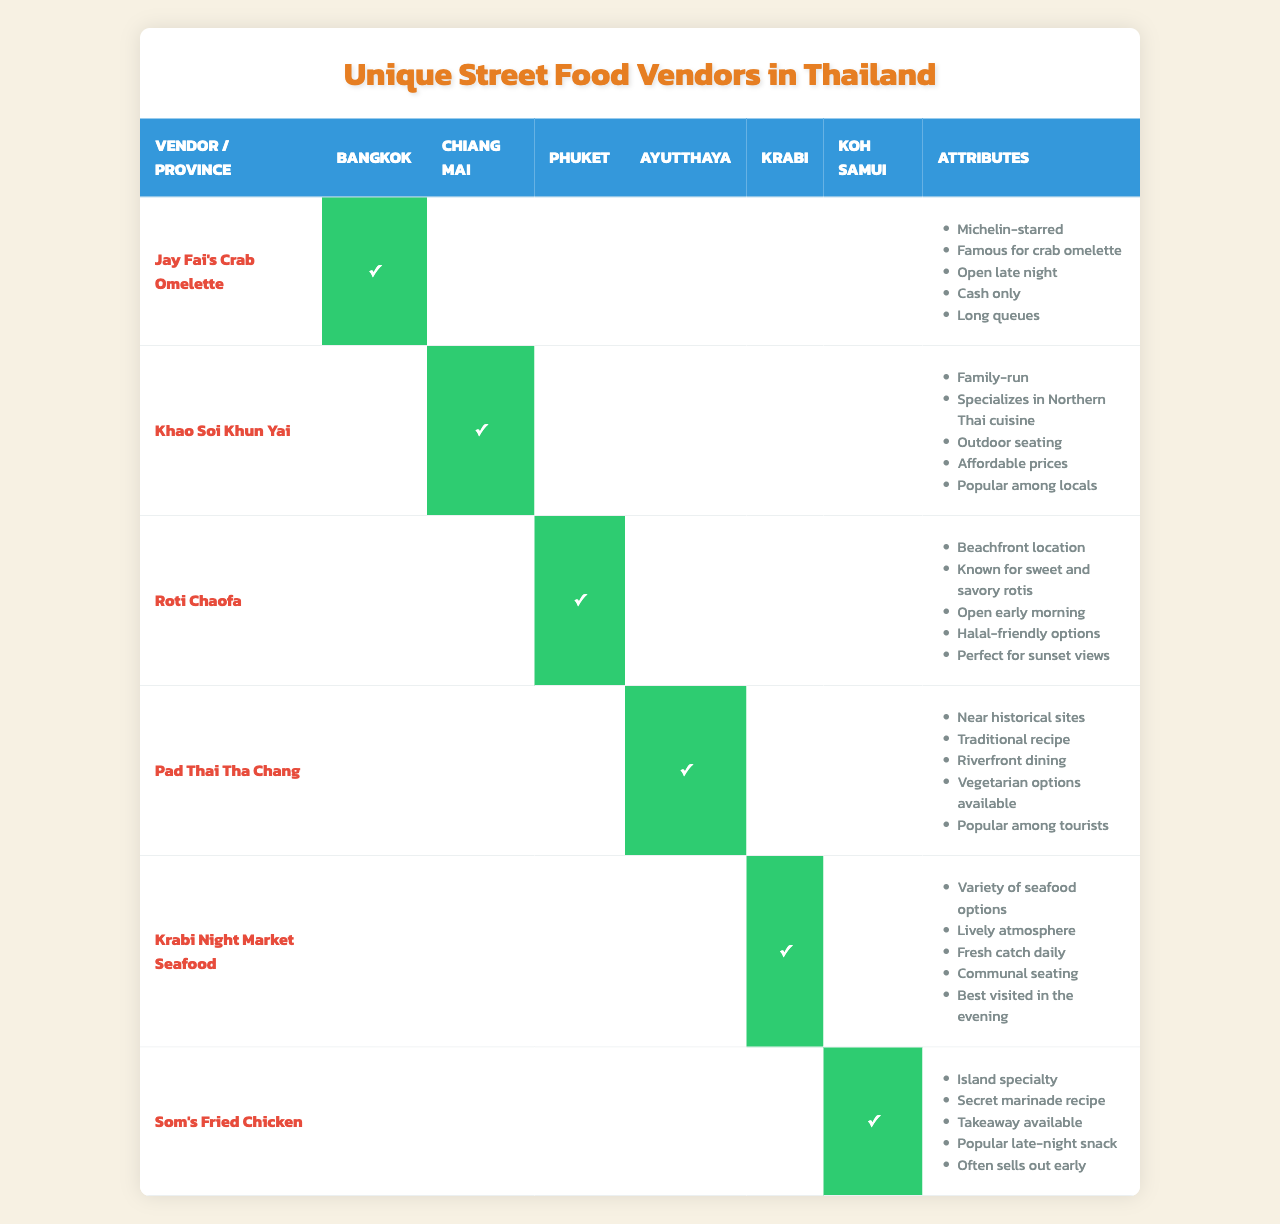What street food vendor is unique to Bangkok? According to the table, "Jay Fai's Crab Omelette" is the vendor listed under Bangkok.
Answer: Jay Fai's Crab Omelette Which vendor is known for Northern Thai cuisine? The table shows that "Khao Soi Khun Yai" specializes in Northern Thai cuisine and is located in Chiang Mai.
Answer: Khao Soi Khun Yai Is "Som's Fried Chicken" a Michelin-starred vendor? The table indicates that "Som's Fried Chicken," located in Koh Samui, does not mention being Michelin-starred in its attributes.
Answer: No How many vendors are listed for Krabi? The table lists one vendor for Krabi, which is "Krabi Night Market Seafood."
Answer: 1 Which vendor offers a beachfront location and halal-friendly options? According to the attributes in the table, "Roti Chaofa" is the vendor that provides a beachfront location and halal-friendly options in Phuket.
Answer: Roti Chaofa Are there any vendors that provide vegetarian options? The table states that "Pad Thai Tha Chang" offers vegetarian options, indicating that it is one of the vendors providing such options.
Answer: Yes Which province has a street vendor with a secret marinade recipe? "Som's Fried Chicken," located in Koh Samui, is the vendor described as having a secret marinade recipe.
Answer: Koh Samui Which vendor is popular among locals and known for outdoor seating? "Khao Soi Khun Yai" in Chiang Mai is popular among locals and features outdoor seating, according to the attributes in the table.
Answer: Khao Soi Khun Yai What is the unique feature of "Krabi Night Market Seafood"? The table lists multiple attributes for "Krabi Night Market Seafood," highlighting its variety of seafood options, lively atmosphere, and that it's best visited in the evening.
Answer: Variety of seafood options Which two vendors are known for attracting a lot of tourists? "Pad Thai Tha Chang" and "Khao Soi Khun Yai" are both popular among tourists based on their respective attributes highlighted in the table.
Answer: Pad Thai Tha Chang and Khao Soi Khun Yai 